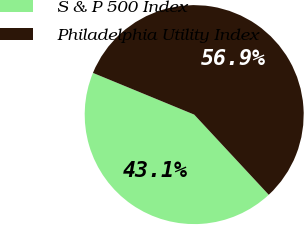Convert chart to OTSL. <chart><loc_0><loc_0><loc_500><loc_500><pie_chart><fcel>S & P 500 Index<fcel>Philadelphia Utility Index<nl><fcel>43.14%<fcel>56.86%<nl></chart> 